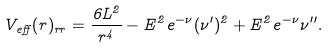Convert formula to latex. <formula><loc_0><loc_0><loc_500><loc_500>V _ { e f f } ( r ) _ { r r } = \frac { 6 L ^ { 2 } } { r ^ { 4 } } - E ^ { 2 } e ^ { - \nu } ( \nu ^ { \prime } ) ^ { 2 } + E ^ { 2 } e ^ { - \nu } \nu ^ { \prime \prime } .</formula> 